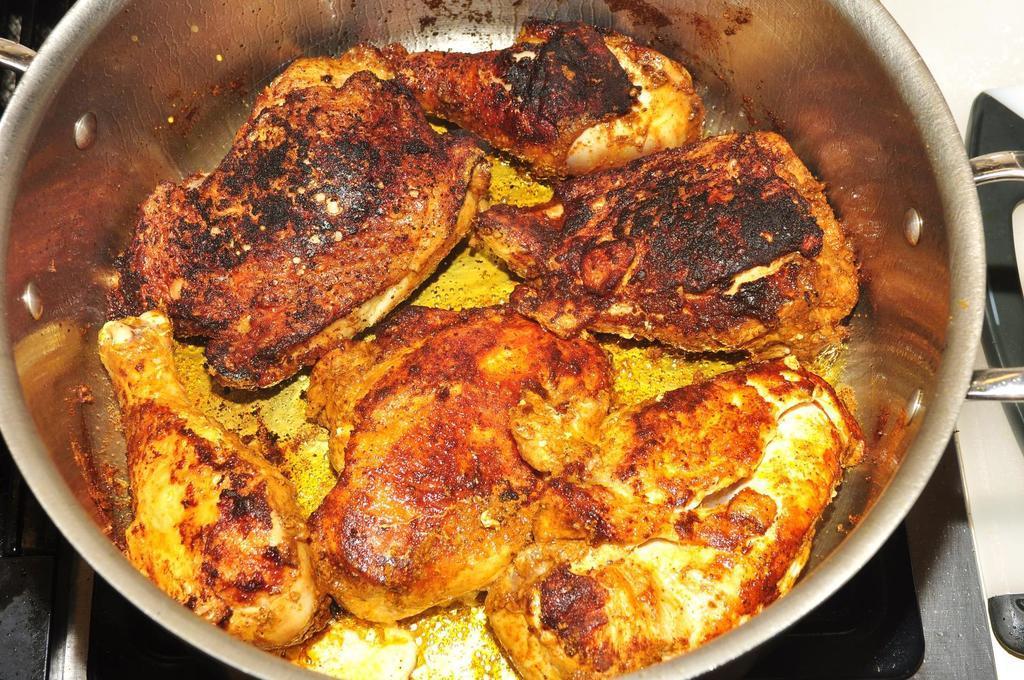Can you describe this image briefly? In the image we can see a container, in the container there is a food item. 